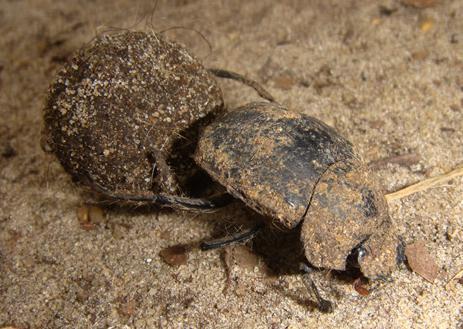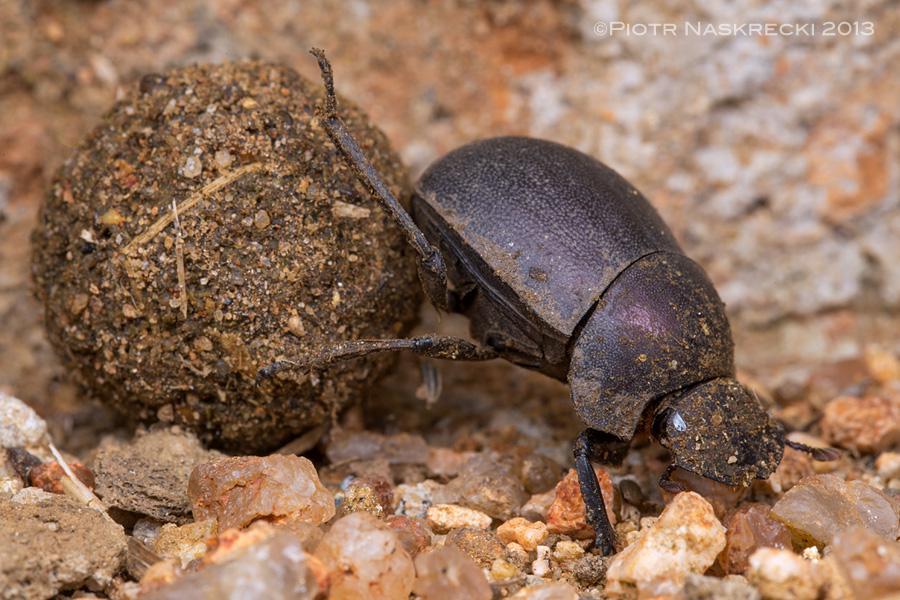The first image is the image on the left, the second image is the image on the right. For the images shown, is this caption "there are two dung beetles on a dung ball" true? Answer yes or no. No. The first image is the image on the left, the second image is the image on the right. Given the left and right images, does the statement "In each of the images only one dung beetle can be seen." hold true? Answer yes or no. Yes. 